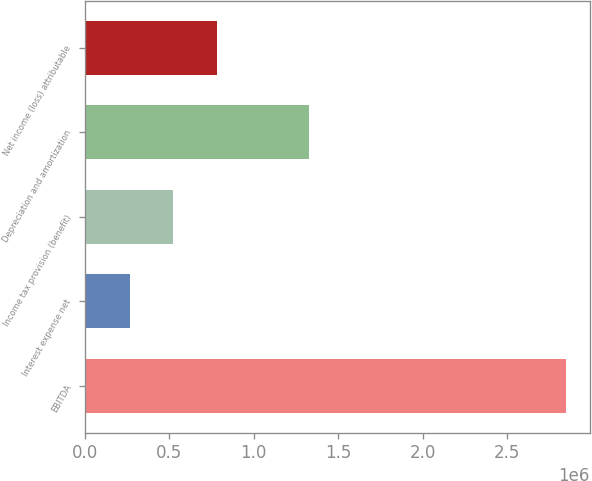Convert chart to OTSL. <chart><loc_0><loc_0><loc_500><loc_500><bar_chart><fcel>EBITDA<fcel>Interest expense net<fcel>Income tax provision (benefit)<fcel>Depreciation and amortization<fcel>Net income (loss) attributable<nl><fcel>2.84701e+06<fcel>267447<fcel>525403<fcel>1.32941e+06<fcel>783360<nl></chart> 